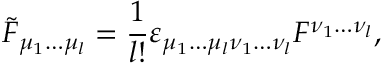<formula> <loc_0><loc_0><loc_500><loc_500>\tilde { F } _ { \mu _ { 1 } \dots \mu _ { l } } = { \frac { 1 } { l ! } } \varepsilon _ { \mu _ { 1 } \dots \mu _ { l } \nu _ { 1 } \dots \nu _ { l } } F ^ { \nu _ { 1 } \dots \nu _ { l } } ,</formula> 